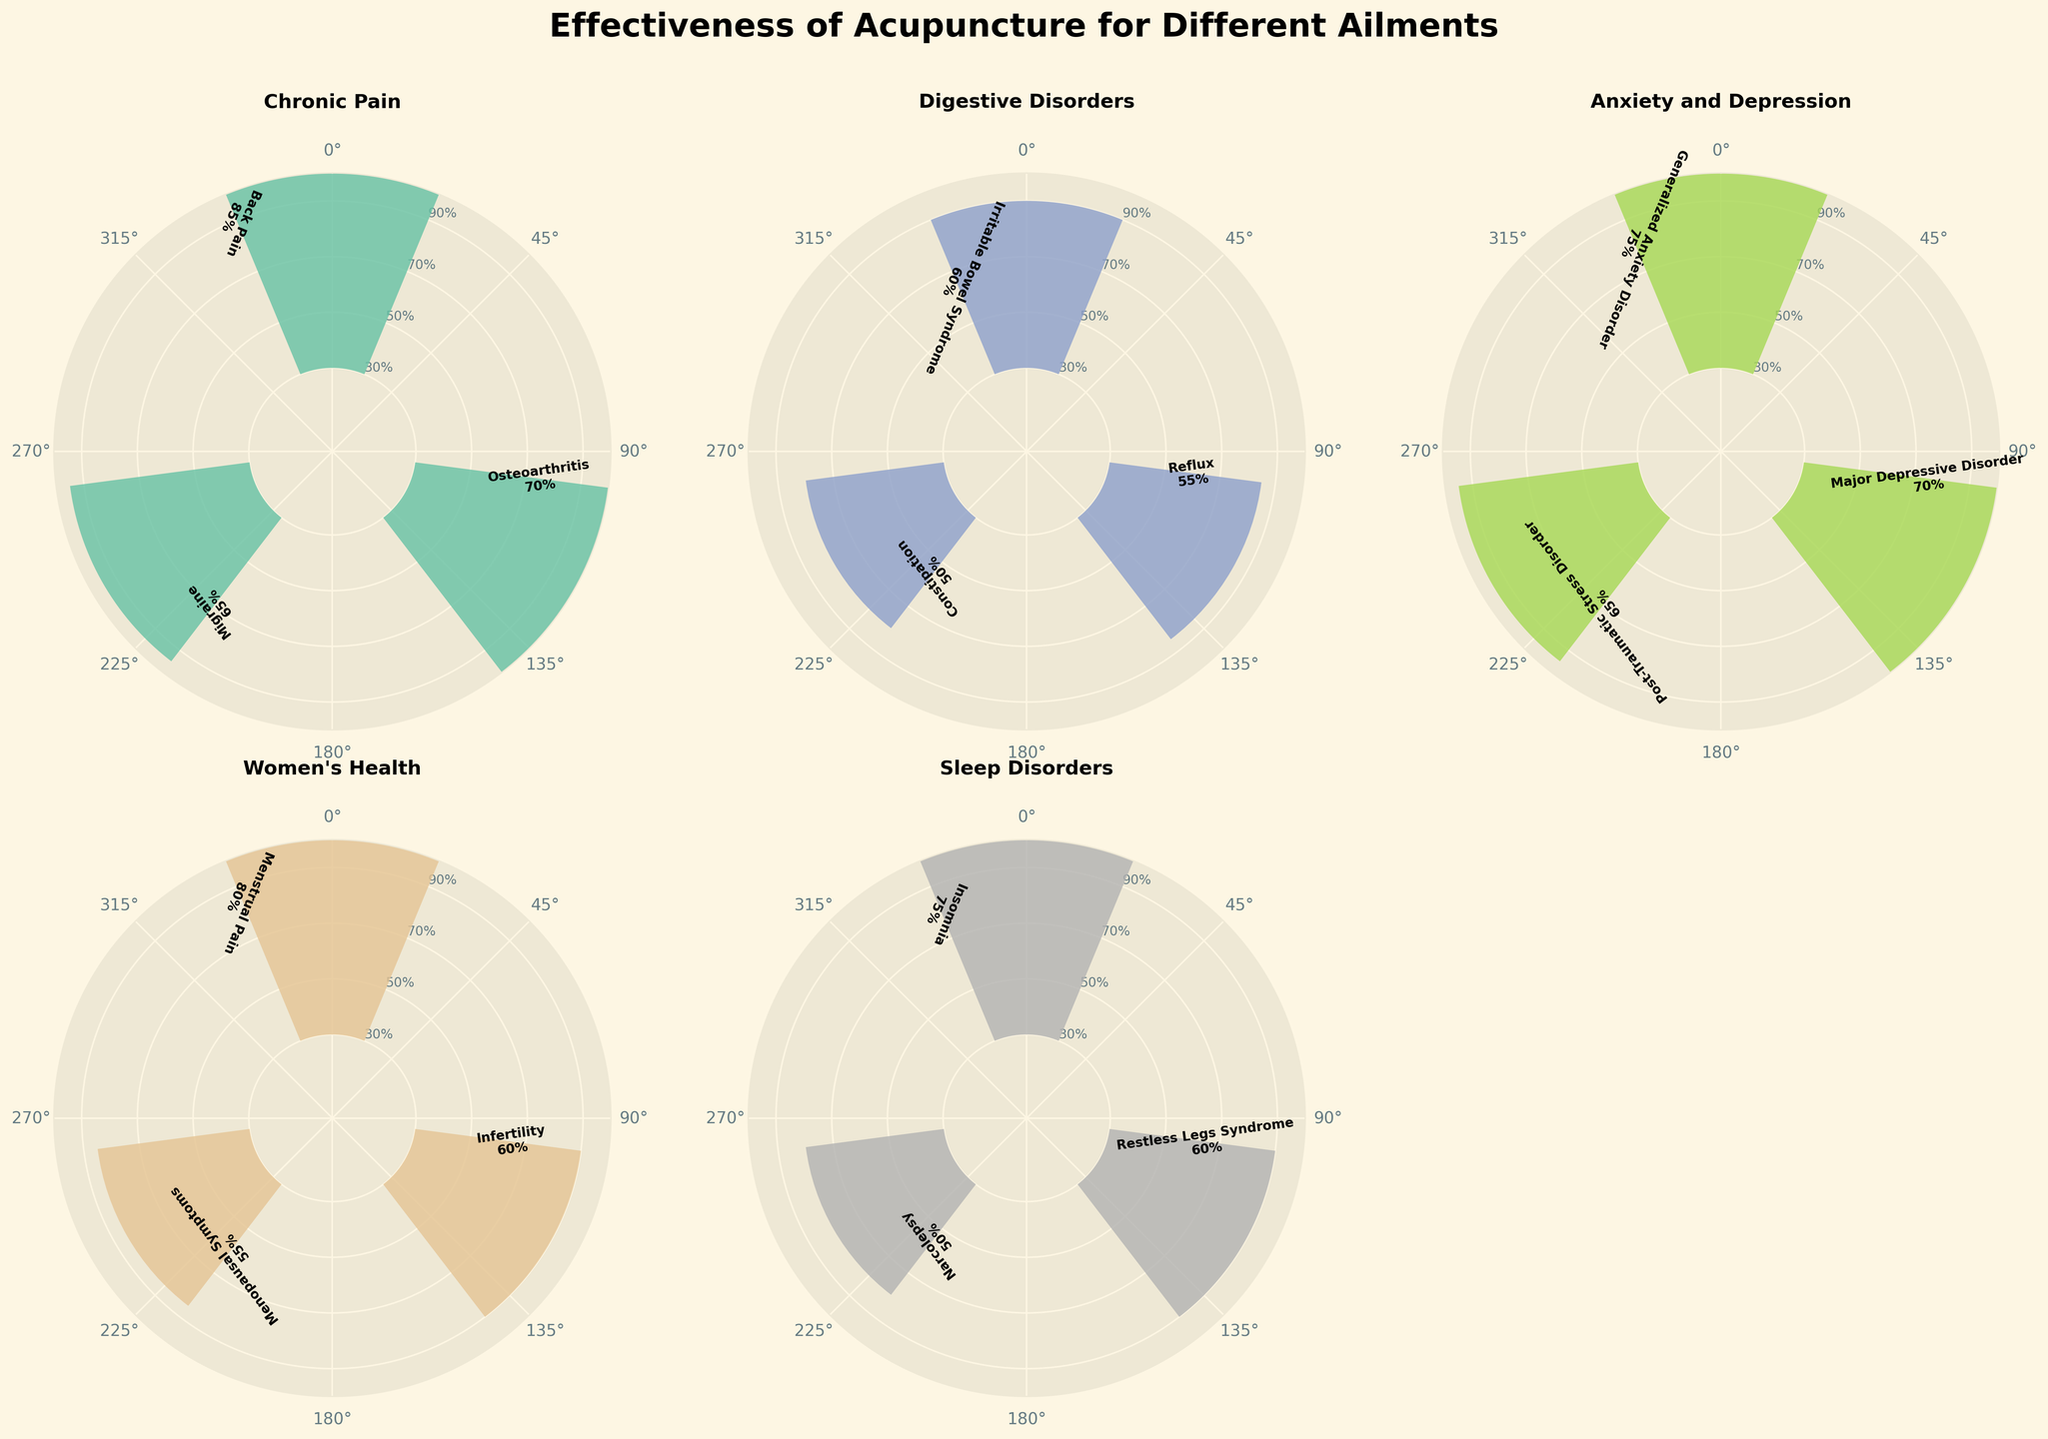What is the overall title of the figure? The title is prominently placed at the top of the figure, indicating the subject of the visual representation.
Answer: Effectiveness of Acupuncture for Different Ailments Which ailment shows the highest positive response for any treatment? By examining the individual subplots, we observe the highest bar in terms of percentage. For Chronic Pain, Back Pain has the highest positive response at 85%.
Answer: Chronic Pain: Back Pain What is the range of positive response percentages for Digestive Disorders? Digestive Disorders show bars representing responses of 60%, 55%, and 50% for different treatments. The range is calculated by subtracting the smallest percentage from the largest.
Answer: 60% - 50% = 10% Compare the effectiveness of acupuncture in treating Insomnia and Restless Legs Syndrome under Sleep Disorders. Which has a higher positive response? By comparing the heights of the bars in the Sleep Disorders subplot, Insomnia has a higher positive response (75%) compared to Restless Legs Syndrome (60%).
Answer: Insomnia How many unique ailments are represented in the figure? The number of subplots indicates the number of unique ailments, excluding any empty subplot. Counting each subplot gives us the total.
Answer: 5 For Anxiety and Depression, which treatment has the lowest positive response percentage? By examining the bars in the Anxiety and Depression subplot, we find that the lowest percentage is for Post-Traumatic Stress Disorder at 65%.
Answer: Post-Traumatic Stress Disorder What is the most common positive response percentage range for the treatments depicted in the figure? By grouping the percentages shown in the various subplots, we see the frequency of different ranges (50-60%, 60-70%, 70-80%, 80-90%).
Answer: 60-70% Which ailment has the most varied range of positive responses across its treatments? By comparing the differences between the highest and lowest positive responses within each ailment category, Women's Health shows the highest range (80% for Menstrual Pain to 55% for Menopausal Symptoms).
Answer: Women's Health Are there any ailments where all treatments show a positive response percentage above 60%? By reviewing the bars and their corresponding percentages for each ailment, Chronic Pain and Anxiety and Depression both show all treatments with responses above 60%.
Answer: Chronic Pain, Anxiety and Depression For Women's Health, what is the average positive response percentage across all treatments? Adding up the positive response percentages for Women's Health treatments (80%, 60%, 55%) and dividing by the total number of treatments (3). (80 + 60 + 55) / 3 = 195 / 3 = 65%.
Answer: 65% 